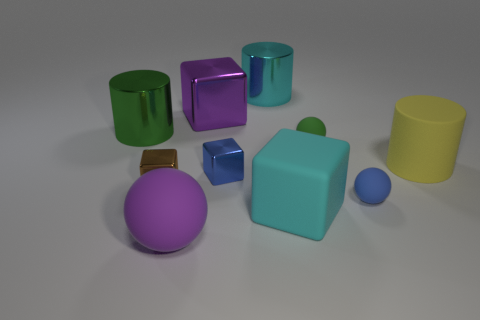Are there the same number of green metal objects that are behind the green metallic cylinder and big red blocks?
Your response must be concise. Yes. Is the size of the blue rubber ball the same as the green rubber thing?
Provide a short and direct response. Yes. The shiny thing that is to the right of the big purple metal cube and in front of the big green cylinder is what color?
Your answer should be compact. Blue. There is a cyan object that is behind the green object right of the big purple ball; what is it made of?
Your answer should be very brief. Metal. What size is the blue shiny thing that is the same shape as the purple metal thing?
Your answer should be very brief. Small. Is the color of the large matte object that is in front of the big cyan matte thing the same as the big shiny block?
Your answer should be very brief. Yes. Is the number of tiny blue things less than the number of matte things?
Give a very brief answer. Yes. How many other things are the same color as the large matte sphere?
Provide a short and direct response. 1. Is the small block that is on the left side of the big ball made of the same material as the blue cube?
Give a very brief answer. Yes. What is the big cylinder that is left of the large cyan metal thing made of?
Give a very brief answer. Metal. 